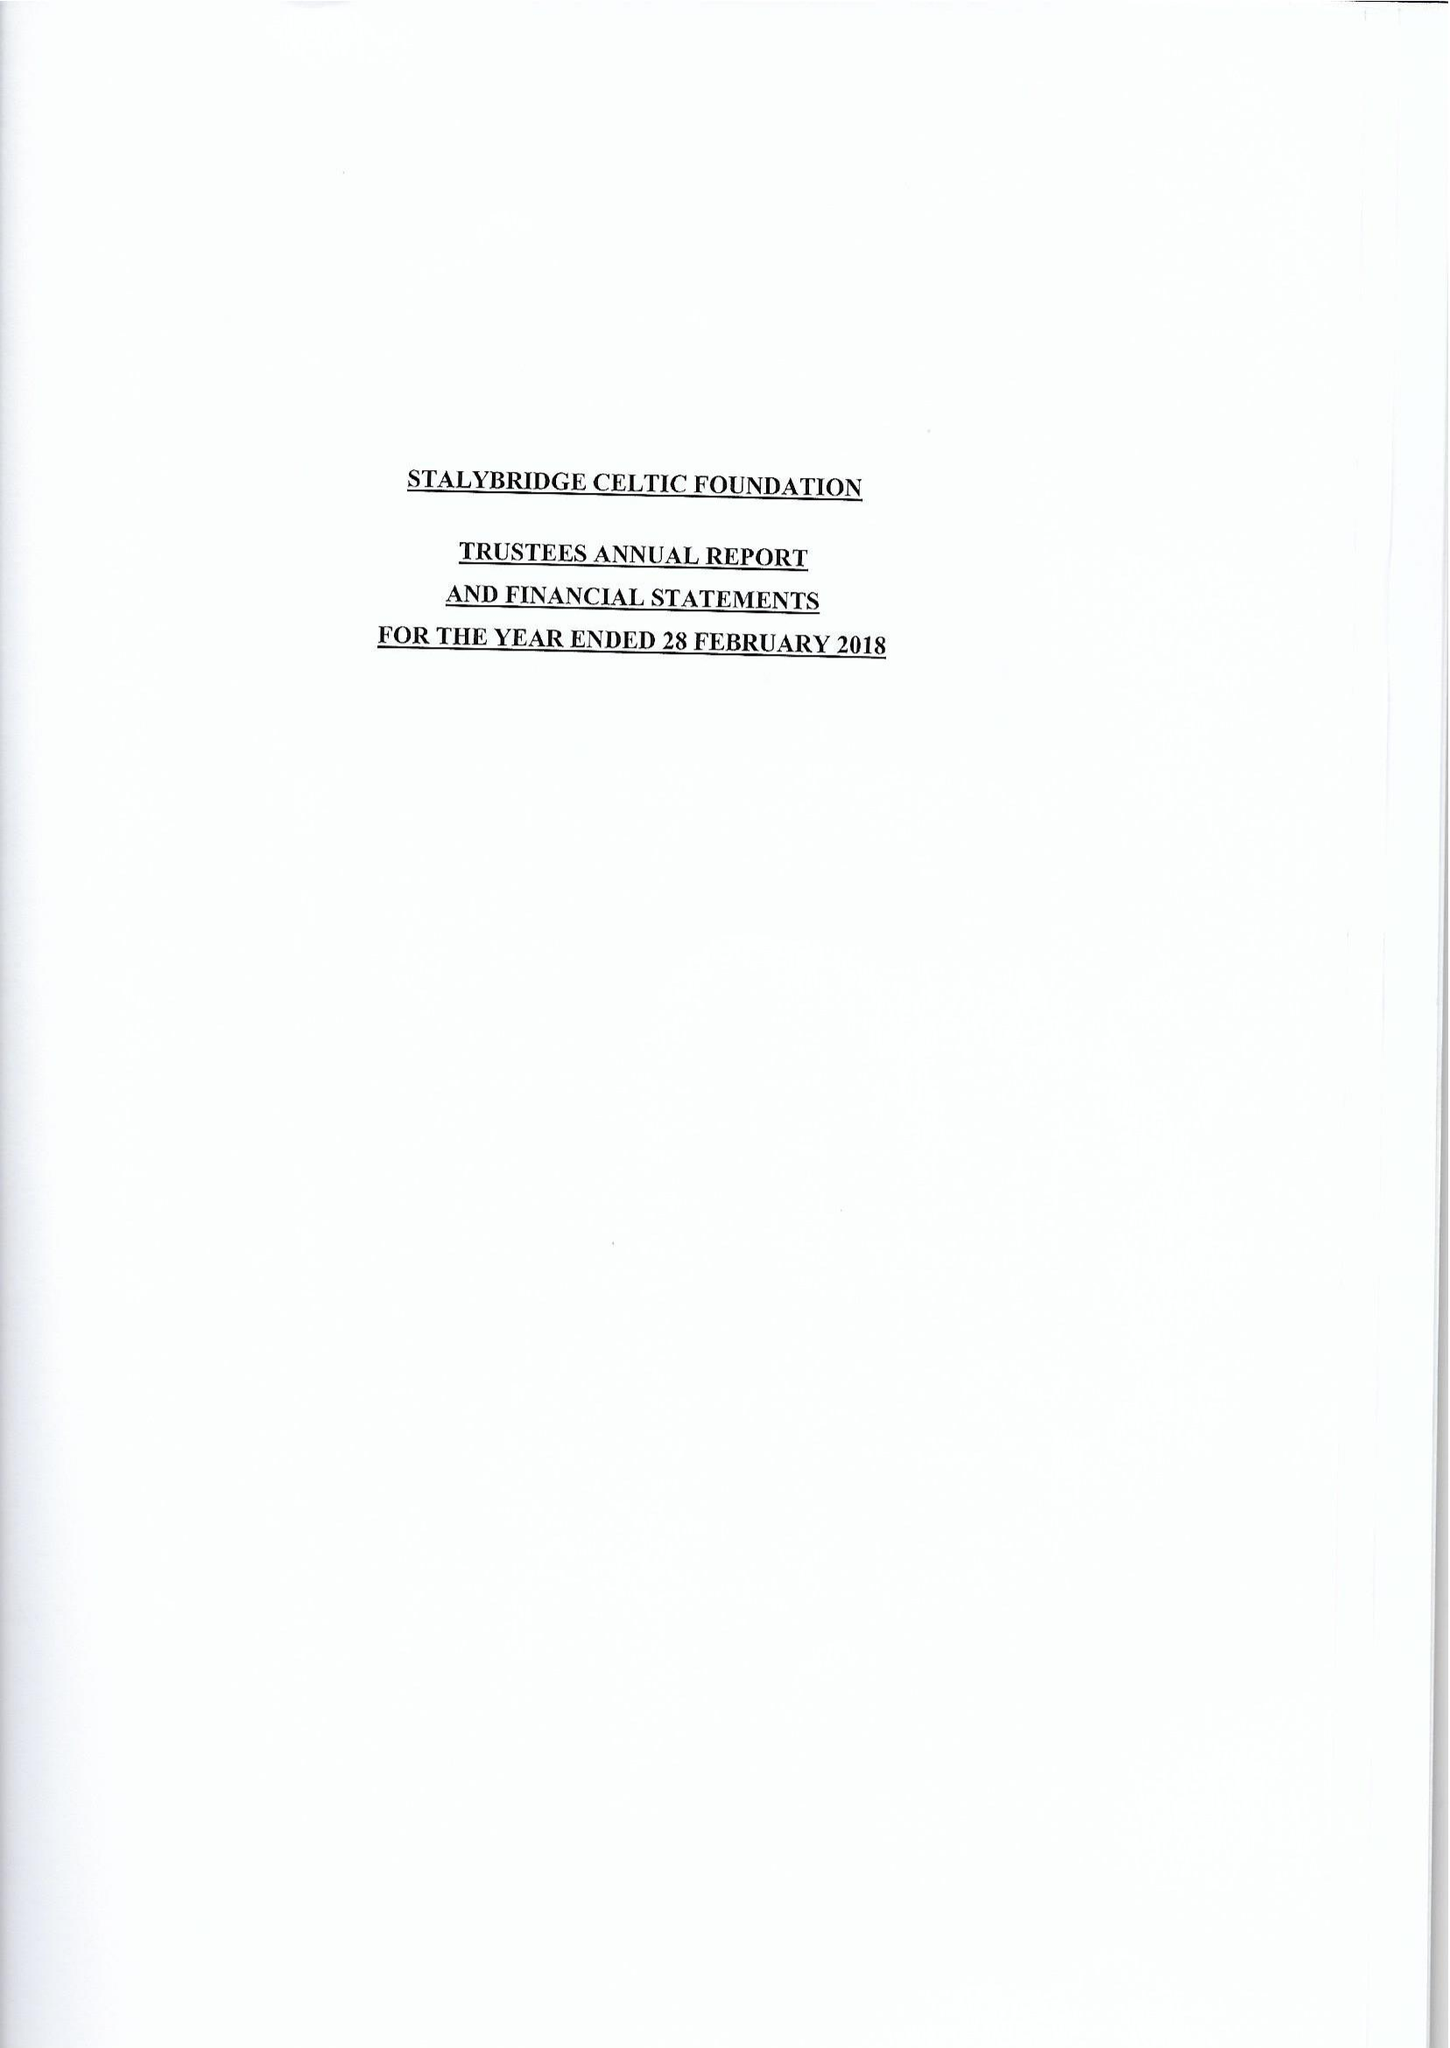What is the value for the spending_annually_in_british_pounds?
Answer the question using a single word or phrase. 28125.00 